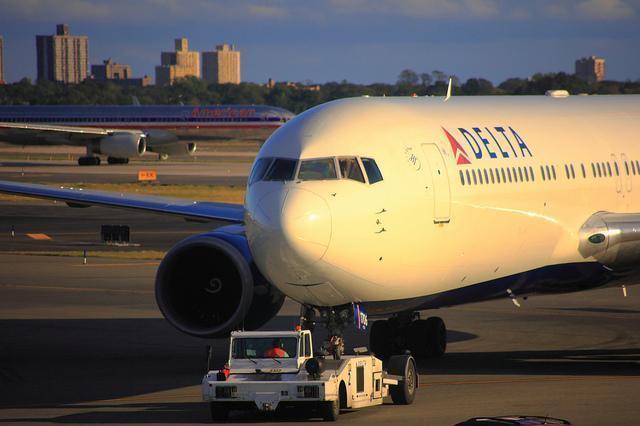What is the last letter of the name that appears on the plane?
Choose the right answer from the provided options to respond to the question.
Options: N, w, , e. . 